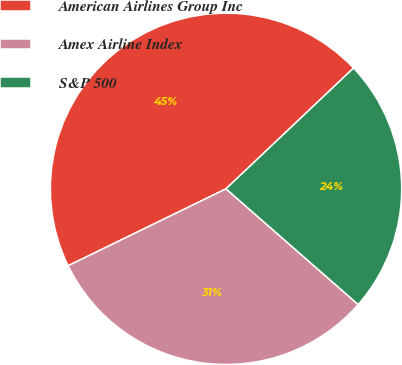<chart> <loc_0><loc_0><loc_500><loc_500><pie_chart><fcel>American Airlines Group Inc<fcel>Amex Airline Index<fcel>S&P 500<nl><fcel>45.15%<fcel>31.34%<fcel>23.51%<nl></chart> 